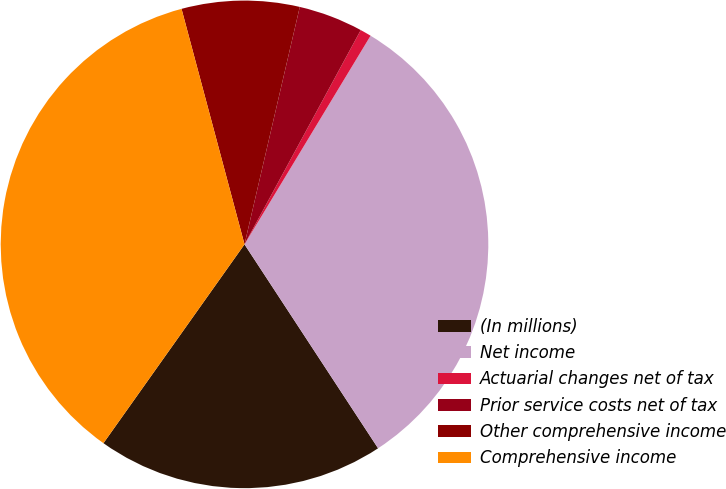<chart> <loc_0><loc_0><loc_500><loc_500><pie_chart><fcel>(In millions)<fcel>Net income<fcel>Actuarial changes net of tax<fcel>Prior service costs net of tax<fcel>Other comprehensive income<fcel>Comprehensive income<nl><fcel>19.05%<fcel>32.12%<fcel>0.74%<fcel>4.27%<fcel>7.8%<fcel>36.02%<nl></chart> 